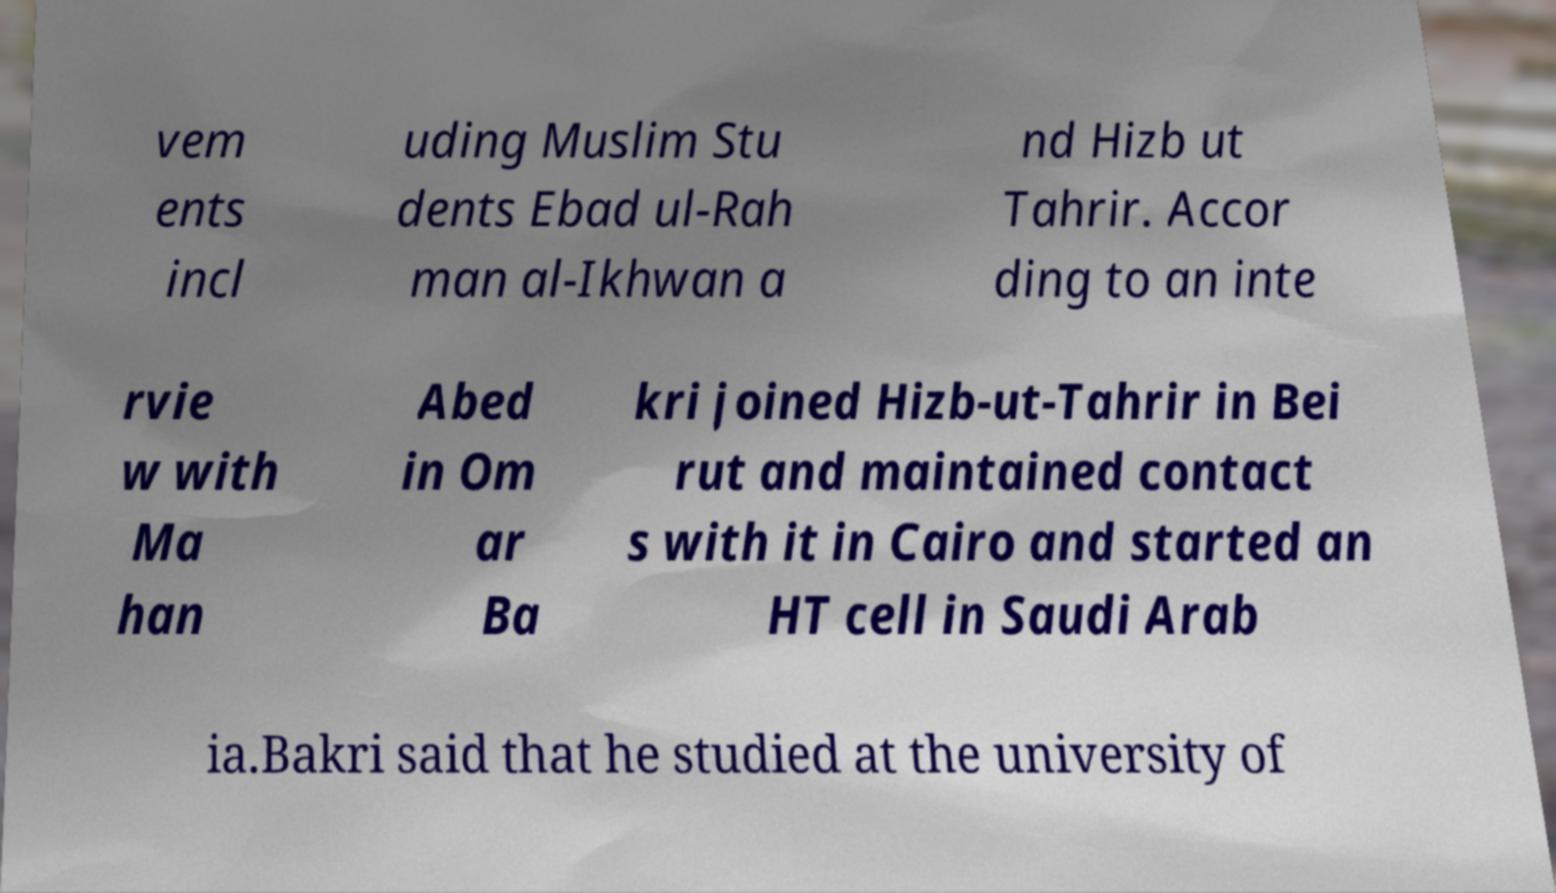Please identify and transcribe the text found in this image. vem ents incl uding Muslim Stu dents Ebad ul-Rah man al-Ikhwan a nd Hizb ut Tahrir. Accor ding to an inte rvie w with Ma han Abed in Om ar Ba kri joined Hizb-ut-Tahrir in Bei rut and maintained contact s with it in Cairo and started an HT cell in Saudi Arab ia.Bakri said that he studied at the university of 